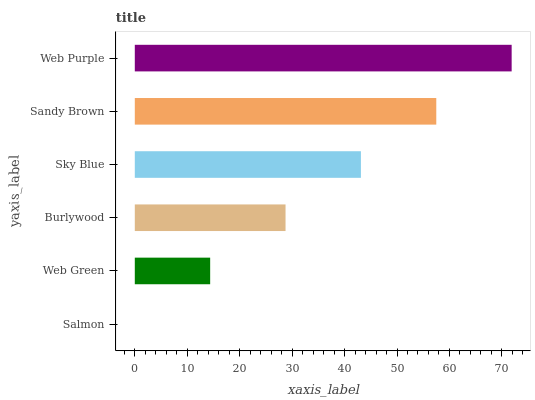Is Salmon the minimum?
Answer yes or no. Yes. Is Web Purple the maximum?
Answer yes or no. Yes. Is Web Green the minimum?
Answer yes or no. No. Is Web Green the maximum?
Answer yes or no. No. Is Web Green greater than Salmon?
Answer yes or no. Yes. Is Salmon less than Web Green?
Answer yes or no. Yes. Is Salmon greater than Web Green?
Answer yes or no. No. Is Web Green less than Salmon?
Answer yes or no. No. Is Sky Blue the high median?
Answer yes or no. Yes. Is Burlywood the low median?
Answer yes or no. Yes. Is Salmon the high median?
Answer yes or no. No. Is Sandy Brown the low median?
Answer yes or no. No. 